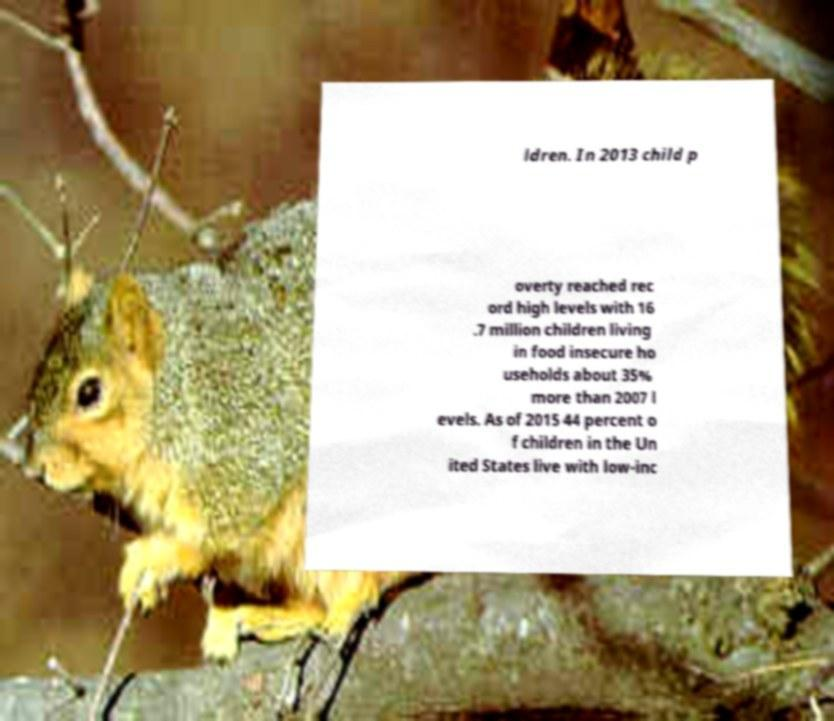Please read and relay the text visible in this image. What does it say? ldren. In 2013 child p overty reached rec ord high levels with 16 .7 million children living in food insecure ho useholds about 35% more than 2007 l evels. As of 2015 44 percent o f children in the Un ited States live with low-inc 